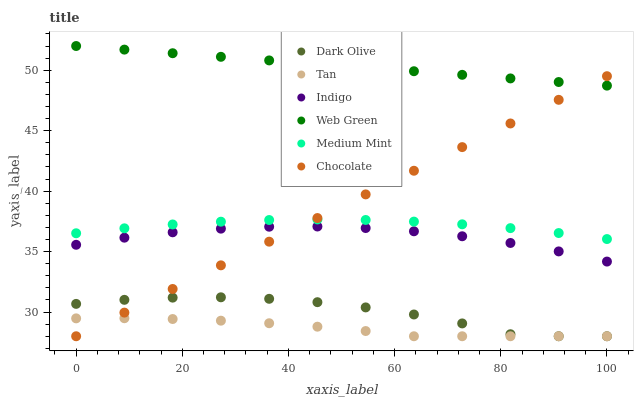Does Tan have the minimum area under the curve?
Answer yes or no. Yes. Does Web Green have the maximum area under the curve?
Answer yes or no. Yes. Does Indigo have the minimum area under the curve?
Answer yes or no. No. Does Indigo have the maximum area under the curve?
Answer yes or no. No. Is Web Green the smoothest?
Answer yes or no. Yes. Is Dark Olive the roughest?
Answer yes or no. Yes. Is Indigo the smoothest?
Answer yes or no. No. Is Indigo the roughest?
Answer yes or no. No. Does Dark Olive have the lowest value?
Answer yes or no. Yes. Does Indigo have the lowest value?
Answer yes or no. No. Does Web Green have the highest value?
Answer yes or no. Yes. Does Indigo have the highest value?
Answer yes or no. No. Is Indigo less than Medium Mint?
Answer yes or no. Yes. Is Web Green greater than Dark Olive?
Answer yes or no. Yes. Does Dark Olive intersect Tan?
Answer yes or no. Yes. Is Dark Olive less than Tan?
Answer yes or no. No. Is Dark Olive greater than Tan?
Answer yes or no. No. Does Indigo intersect Medium Mint?
Answer yes or no. No. 